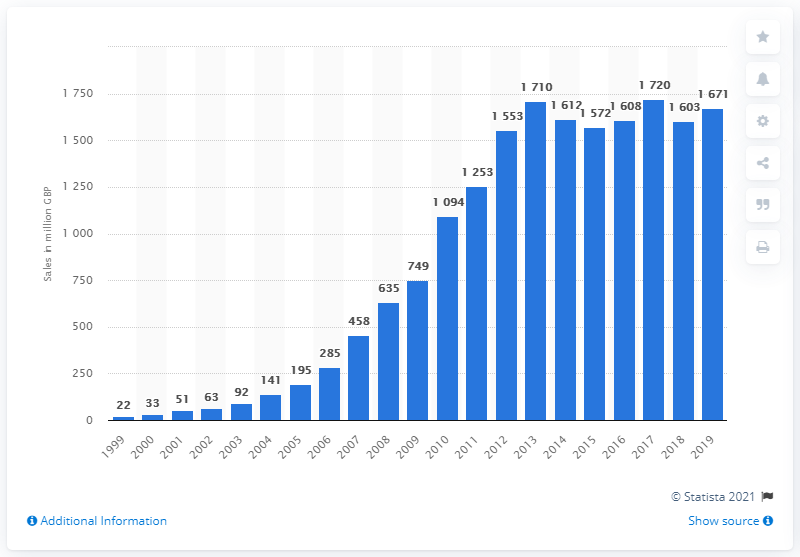Indicate a few pertinent items in this graphic. In 2019, the sales of Fairtrade food and drink products in the UK totaled 1,671. In 2005, the total amount of British pounds spent on Fairtrade food and drink products in the United Kingdom was 195 million. 